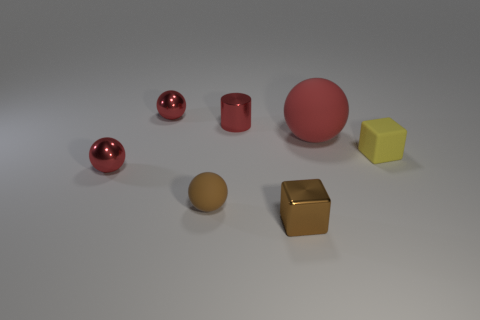Subtract all brown rubber spheres. How many spheres are left? 3 Add 1 small rubber objects. How many objects exist? 8 Subtract 2 blocks. How many blocks are left? 0 Subtract all brown balls. How many balls are left? 3 Add 4 tiny blocks. How many tiny blocks exist? 6 Subtract 0 red blocks. How many objects are left? 7 Subtract all blocks. How many objects are left? 5 Subtract all cyan balls. Subtract all green cubes. How many balls are left? 4 Subtract all cyan cylinders. How many yellow blocks are left? 1 Subtract all big red balls. Subtract all small red cylinders. How many objects are left? 5 